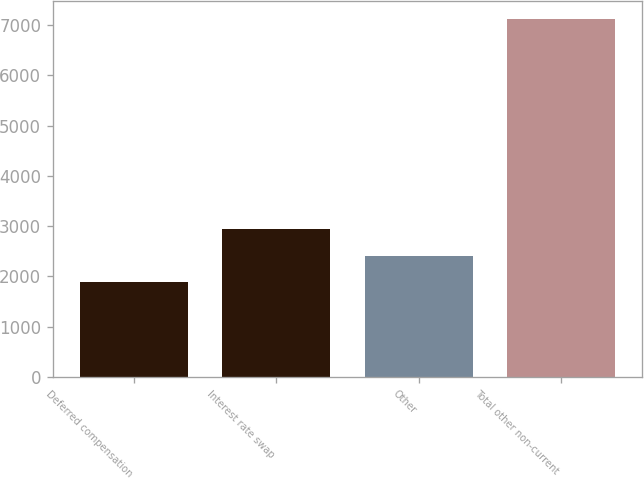Convert chart to OTSL. <chart><loc_0><loc_0><loc_500><loc_500><bar_chart><fcel>Deferred compensation<fcel>Interest rate swap<fcel>Other<fcel>Total other non-current<nl><fcel>1888<fcel>2935<fcel>2411.5<fcel>7123<nl></chart> 